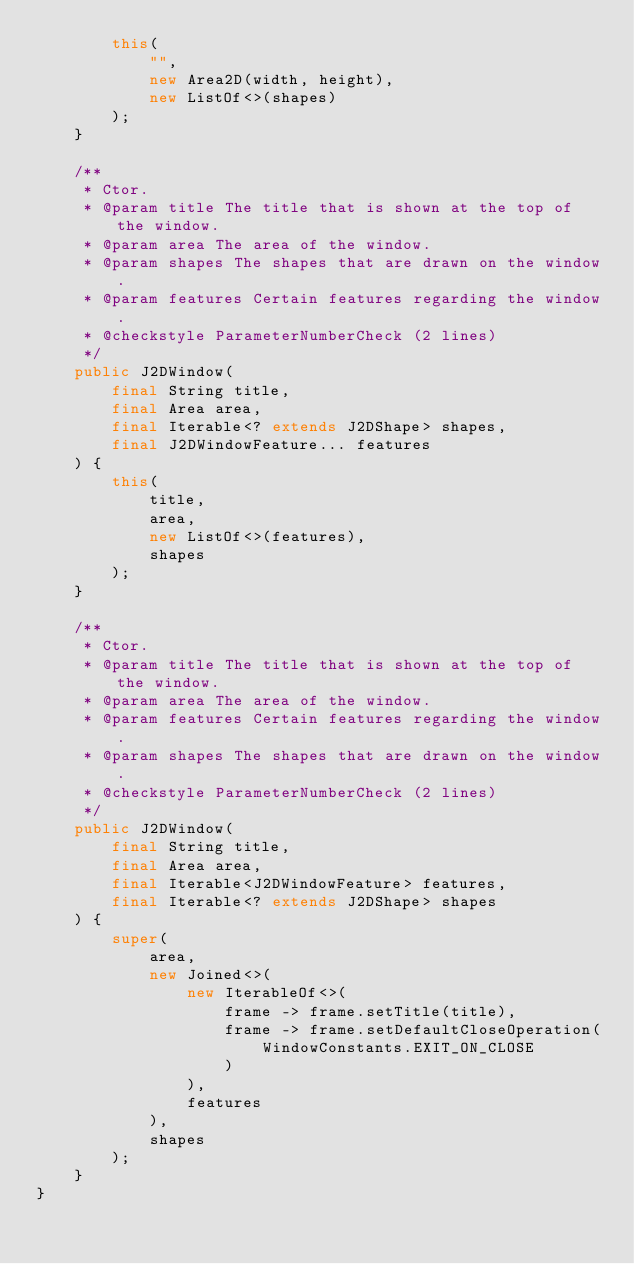Convert code to text. <code><loc_0><loc_0><loc_500><loc_500><_Java_>        this(
            "",
            new Area2D(width, height),
            new ListOf<>(shapes)
        );
    }

    /**
     * Ctor.
     * @param title The title that is shown at the top of the window.
     * @param area The area of the window.
     * @param shapes The shapes that are drawn on the window.
     * @param features Certain features regarding the window.
     * @checkstyle ParameterNumberCheck (2 lines)
     */
    public J2DWindow(
        final String title,
        final Area area,
        final Iterable<? extends J2DShape> shapes,
        final J2DWindowFeature... features
    ) {
        this(
            title,
            area,
            new ListOf<>(features),
            shapes
        );
    }

    /**
     * Ctor.
     * @param title The title that is shown at the top of the window.
     * @param area The area of the window.
     * @param features Certain features regarding the window.
     * @param shapes The shapes that are drawn on the window.
     * @checkstyle ParameterNumberCheck (2 lines)
     */
    public J2DWindow(
        final String title,
        final Area area,
        final Iterable<J2DWindowFeature> features,
        final Iterable<? extends J2DShape> shapes
    ) {
        super(
            area,
            new Joined<>(
                new IterableOf<>(
                    frame -> frame.setTitle(title),
                    frame -> frame.setDefaultCloseOperation(
                        WindowConstants.EXIT_ON_CLOSE
                    )
                ),
                features
            ),
            shapes
        );
    }
}
</code> 